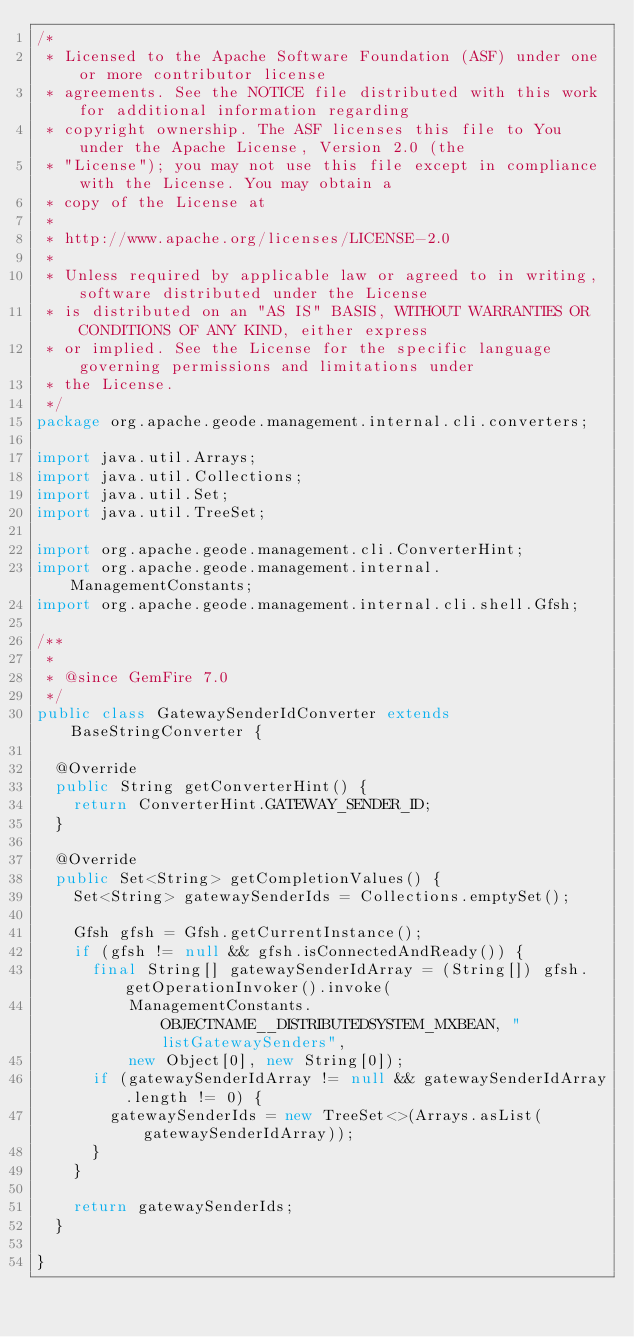Convert code to text. <code><loc_0><loc_0><loc_500><loc_500><_Java_>/*
 * Licensed to the Apache Software Foundation (ASF) under one or more contributor license
 * agreements. See the NOTICE file distributed with this work for additional information regarding
 * copyright ownership. The ASF licenses this file to You under the Apache License, Version 2.0 (the
 * "License"); you may not use this file except in compliance with the License. You may obtain a
 * copy of the License at
 *
 * http://www.apache.org/licenses/LICENSE-2.0
 *
 * Unless required by applicable law or agreed to in writing, software distributed under the License
 * is distributed on an "AS IS" BASIS, WITHOUT WARRANTIES OR CONDITIONS OF ANY KIND, either express
 * or implied. See the License for the specific language governing permissions and limitations under
 * the License.
 */
package org.apache.geode.management.internal.cli.converters;

import java.util.Arrays;
import java.util.Collections;
import java.util.Set;
import java.util.TreeSet;

import org.apache.geode.management.cli.ConverterHint;
import org.apache.geode.management.internal.ManagementConstants;
import org.apache.geode.management.internal.cli.shell.Gfsh;

/**
 *
 * @since GemFire 7.0
 */
public class GatewaySenderIdConverter extends BaseStringConverter {

  @Override
  public String getConverterHint() {
    return ConverterHint.GATEWAY_SENDER_ID;
  }

  @Override
  public Set<String> getCompletionValues() {
    Set<String> gatewaySenderIds = Collections.emptySet();

    Gfsh gfsh = Gfsh.getCurrentInstance();
    if (gfsh != null && gfsh.isConnectedAndReady()) {
      final String[] gatewaySenderIdArray = (String[]) gfsh.getOperationInvoker().invoke(
          ManagementConstants.OBJECTNAME__DISTRIBUTEDSYSTEM_MXBEAN, "listGatewaySenders",
          new Object[0], new String[0]);
      if (gatewaySenderIdArray != null && gatewaySenderIdArray.length != 0) {
        gatewaySenderIds = new TreeSet<>(Arrays.asList(gatewaySenderIdArray));
      }
    }

    return gatewaySenderIds;
  }

}
</code> 